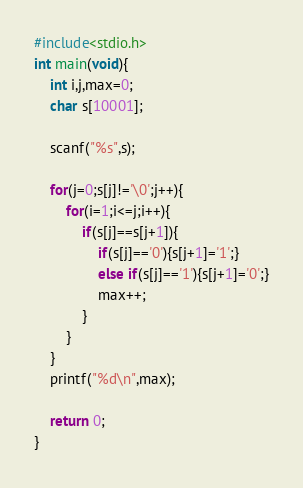Convert code to text. <code><loc_0><loc_0><loc_500><loc_500><_C_>#include<stdio.h>
int main(void){
	int i,j,max=0;
	char s[10001];

	scanf("%s",s);

	for(j=0;s[j]!='\0';j++){
		for(i=1;i<=j;i++){
			if(s[j]==s[j+1]){
				if(s[j]=='0'){s[j+1]='1';}
				else if(s[j]=='1'){s[j+1]='0';}
				max++;
			}
		}
	}
	printf("%d\n",max);

	return 0;
}
</code> 